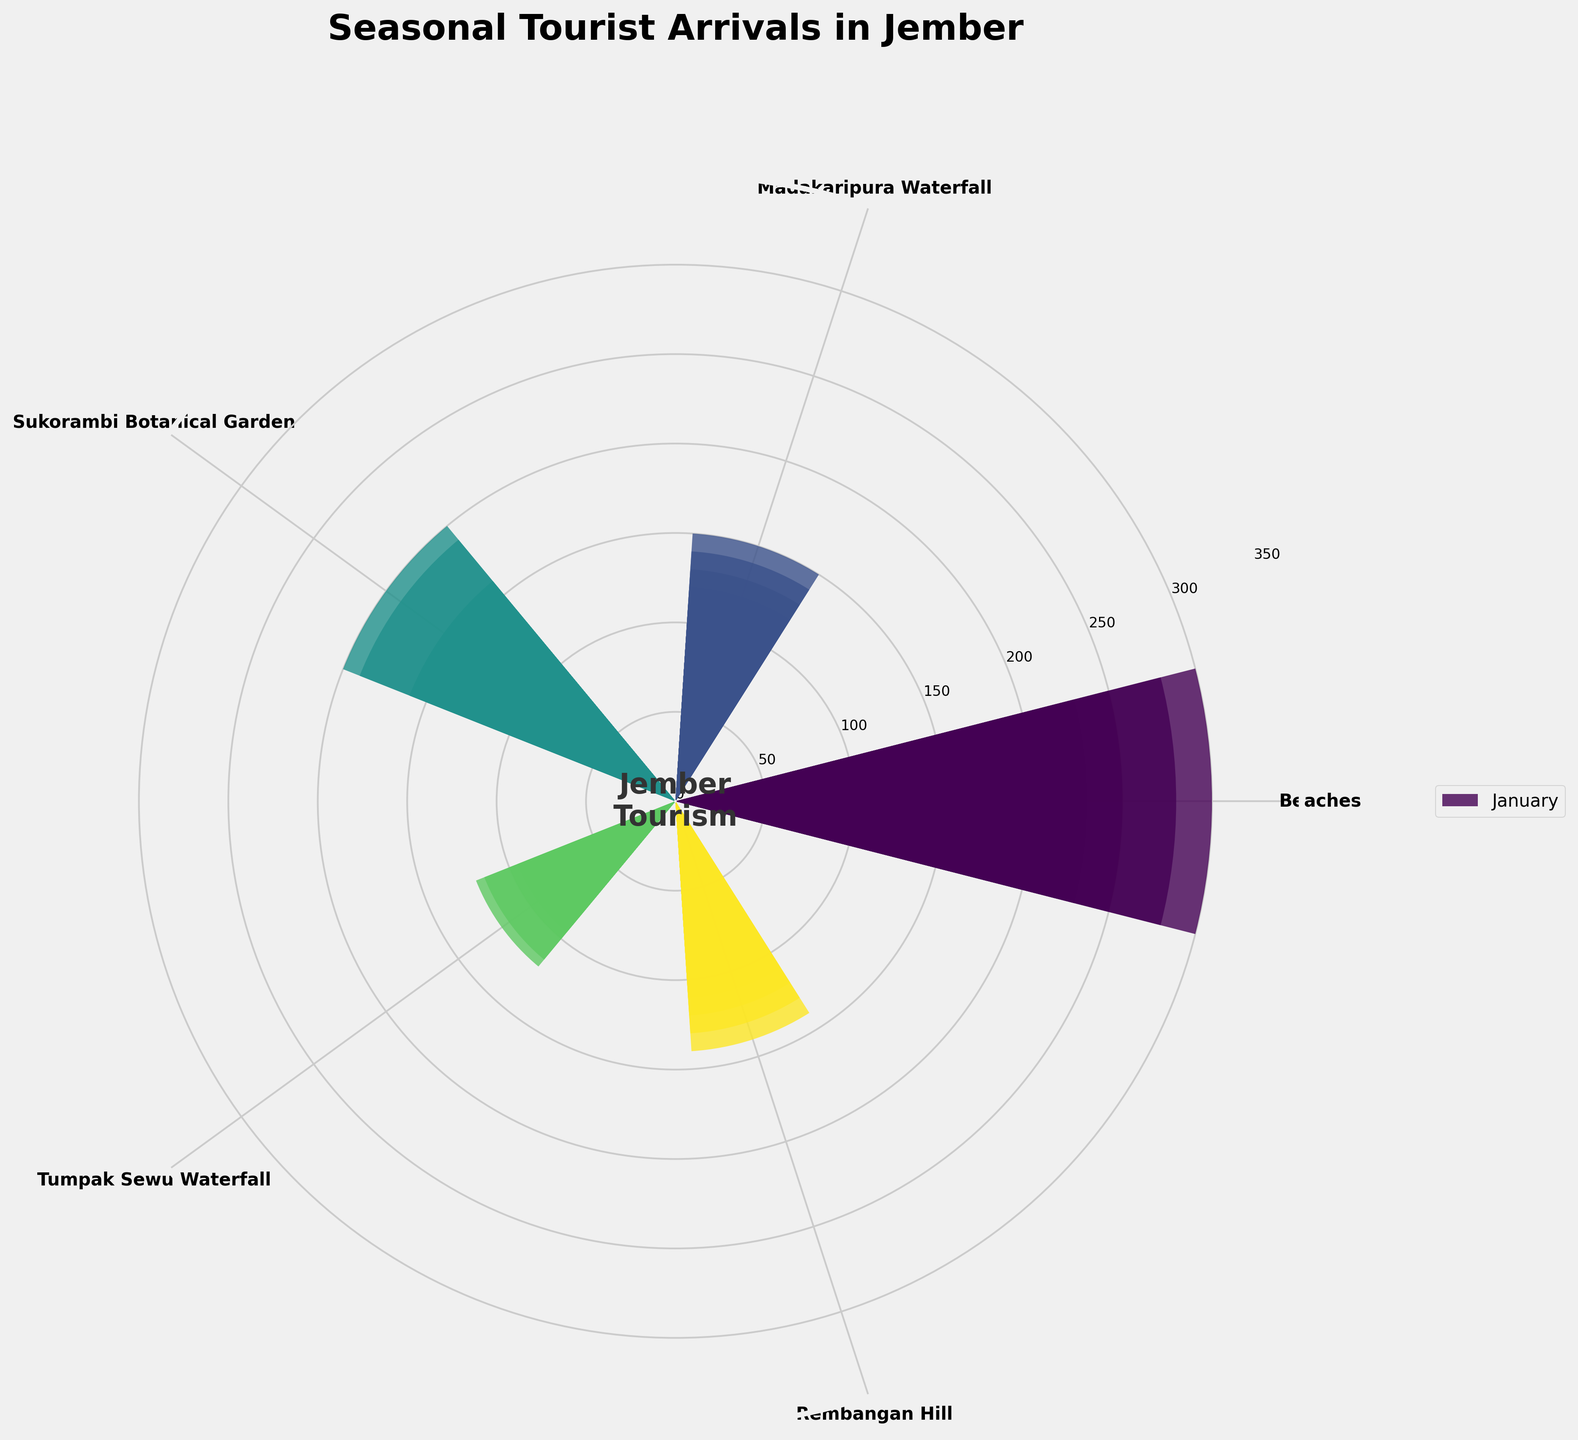What is the title of the chart? The title of the chart is displayed at the top center of the figure. It is "Seasonal Tourist Arrivals in Jember."
Answer: Seasonal Tourist Arrivals in Jember How many tourist attractions are represented in the chart? The number of tourist attractions can be determined by counting the number of labels around the rose chart. There are five labels: Beaches, Madakaripura Waterfall, Sukorambi Botanical Garden, Tumpak Sewu Waterfall, and Rembangan Hill.
Answer: 5 Which tourist attraction has the highest number of visitors in July? To determine this, look at the bars representing each tourist attraction in July. The tallest bar in July corresponds to Beaches.
Answer: Beaches How do the number of visitors to Madakaripura Waterfall in January and December compare? Compare the bar lengths for Madakaripura Waterfall in January and December. Both are equal, indicating the number of visitors is the same in both months.
Answer: Equal Which month had the lowest tourist arrivals for Rembangan Hill, and how many visitors were there? Look at the smallest bar for Rembangan Hill, which appears in February. This bar shows the number of visitors, which is 55.
Answer: February, 55 What is the combined number of visitors to Sukorambi Botanical Garden in May and October? To find this, sum the values for Sukorambi Botanical Garden in May and October (140 + 130).
Answer: 270 Which month had the most total visitors across all tourist attractions? Sum the visitors for each tourist attraction per month and compare. The month with the highest total is July (300 + 150 + 200 + 120 + 140 = 910).
Answer: July How does the number of visitors to Beaches in August compare to Beaches in September? Compare the bar lengths for Beaches in August and September. August has 280 visitors, while September has 230 visitors. August is higher.
Answer: August is higher What is the average number of visitors to Tumpak Sewu Waterfall from January to June? Sum the number of visitors to Tumpak Sewu Waterfall from January to June and then divide by 6: (50 + 45 + 60 + 70 + 85 + 100) / 6 = 410 / 6 ≈ 68.33.
Answer: Approximately 68.33 Is there a month where the number of visitors for all tourist attractions is within the range of 50-200? Check each month to see if all attractions have visitor numbers within 50-200. November fits this range: 170 (Beaches), 90 (Madakaripura Waterfall), 110 (Sukorambi Botanical Garden), 65 (Tumpak Sewu Waterfall), 75 (Rembangan Hill).
Answer: November 